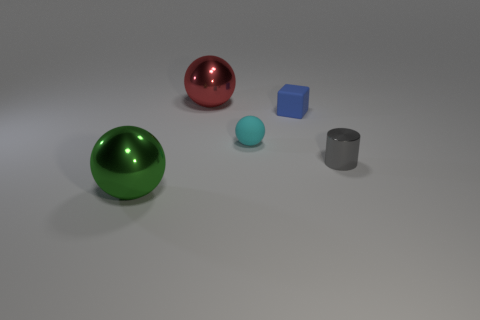Add 1 metal cylinders. How many objects exist? 6 Subtract all balls. How many objects are left? 2 Subtract 0 gray balls. How many objects are left? 5 Subtract all tiny things. Subtract all small cyan things. How many objects are left? 1 Add 5 small rubber cubes. How many small rubber cubes are left? 6 Add 2 yellow objects. How many yellow objects exist? 2 